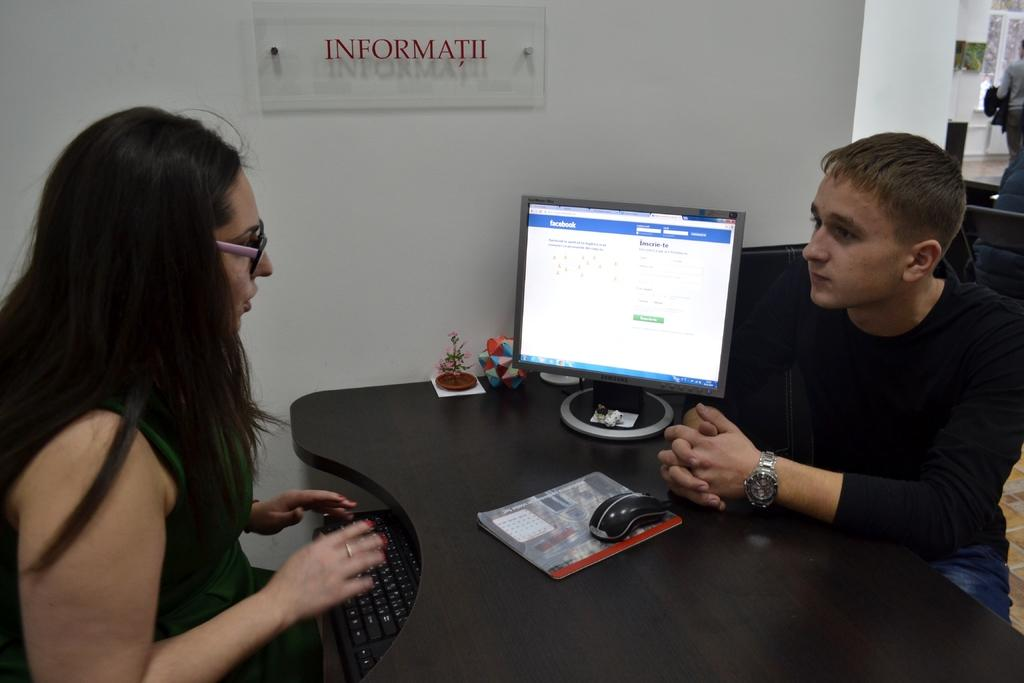Provide a one-sentence caption for the provided image. Two people having a conversation in front of a screen that shows Facebook. 